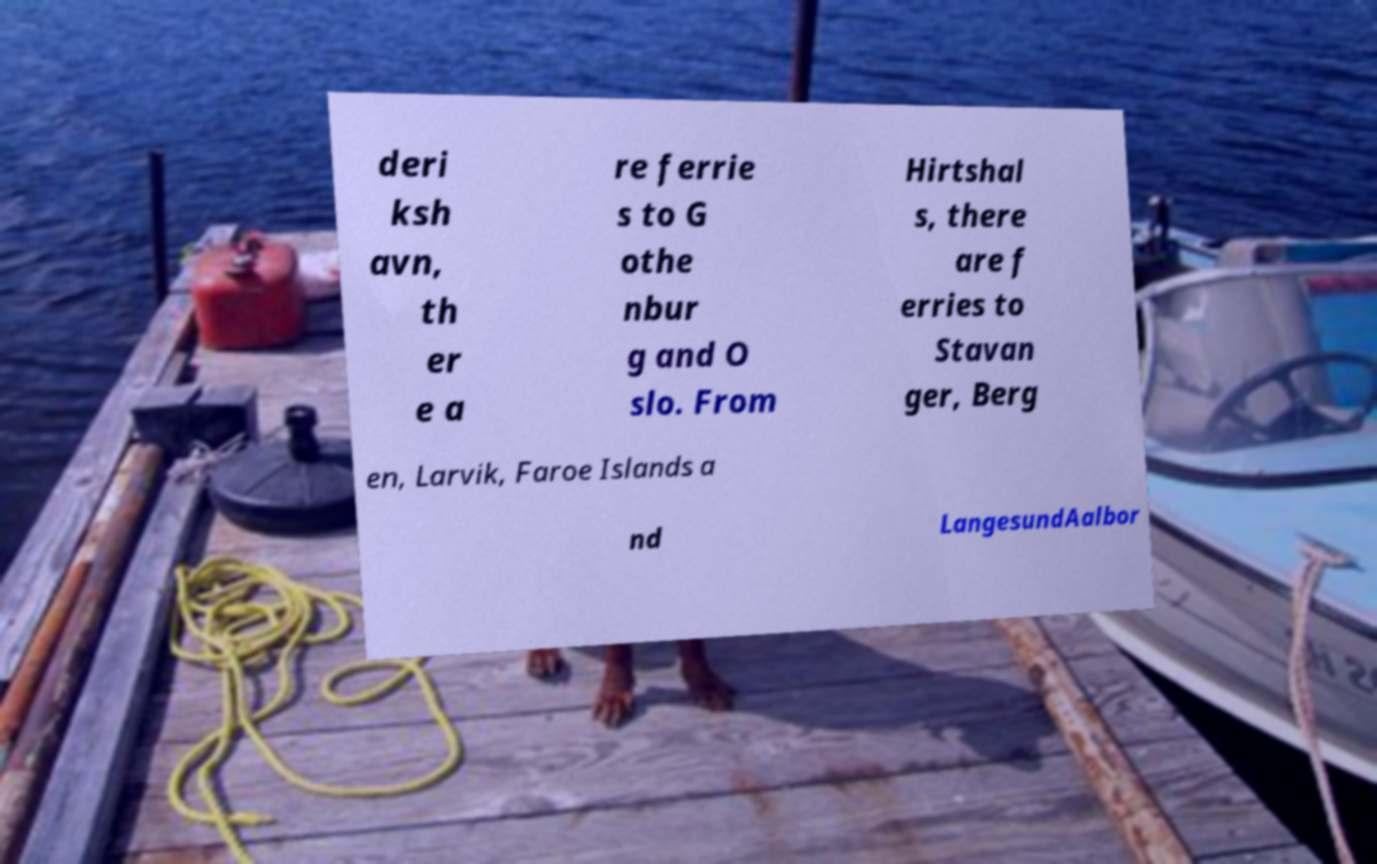Could you extract and type out the text from this image? deri ksh avn, th er e a re ferrie s to G othe nbur g and O slo. From Hirtshal s, there are f erries to Stavan ger, Berg en, Larvik, Faroe Islands a nd LangesundAalbor 